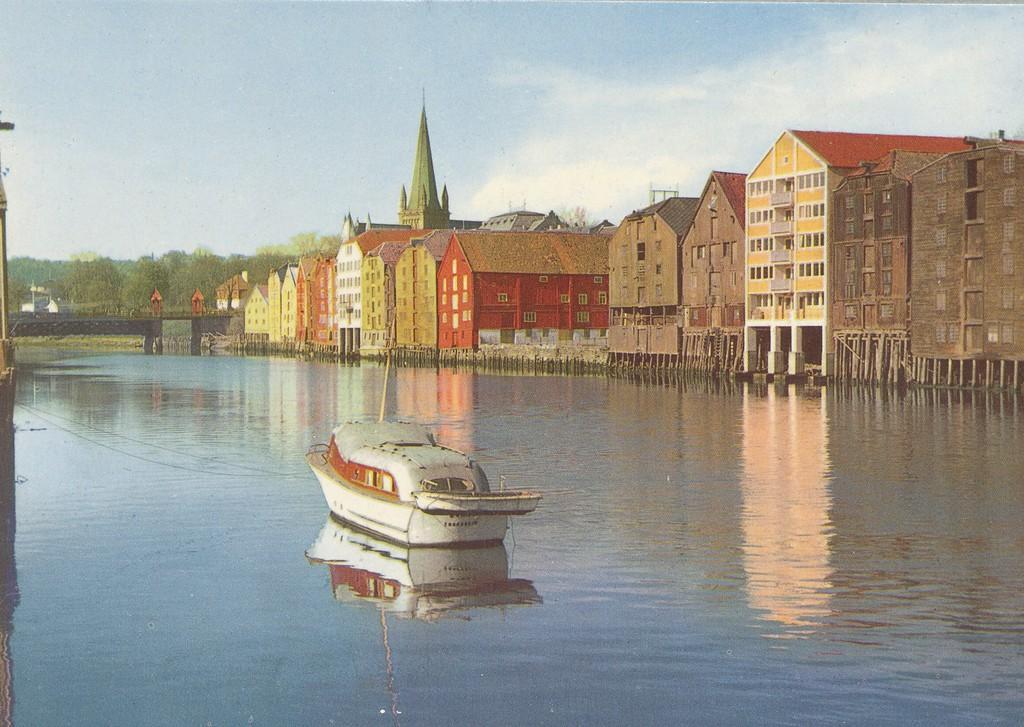Can you describe this image briefly? In this image there is a painting. At the bottom we can see the boat on the water. On the right we can see buildings, house and church. On the left we can see bridge, trees and grass. At the top we can see sky and clouds. 